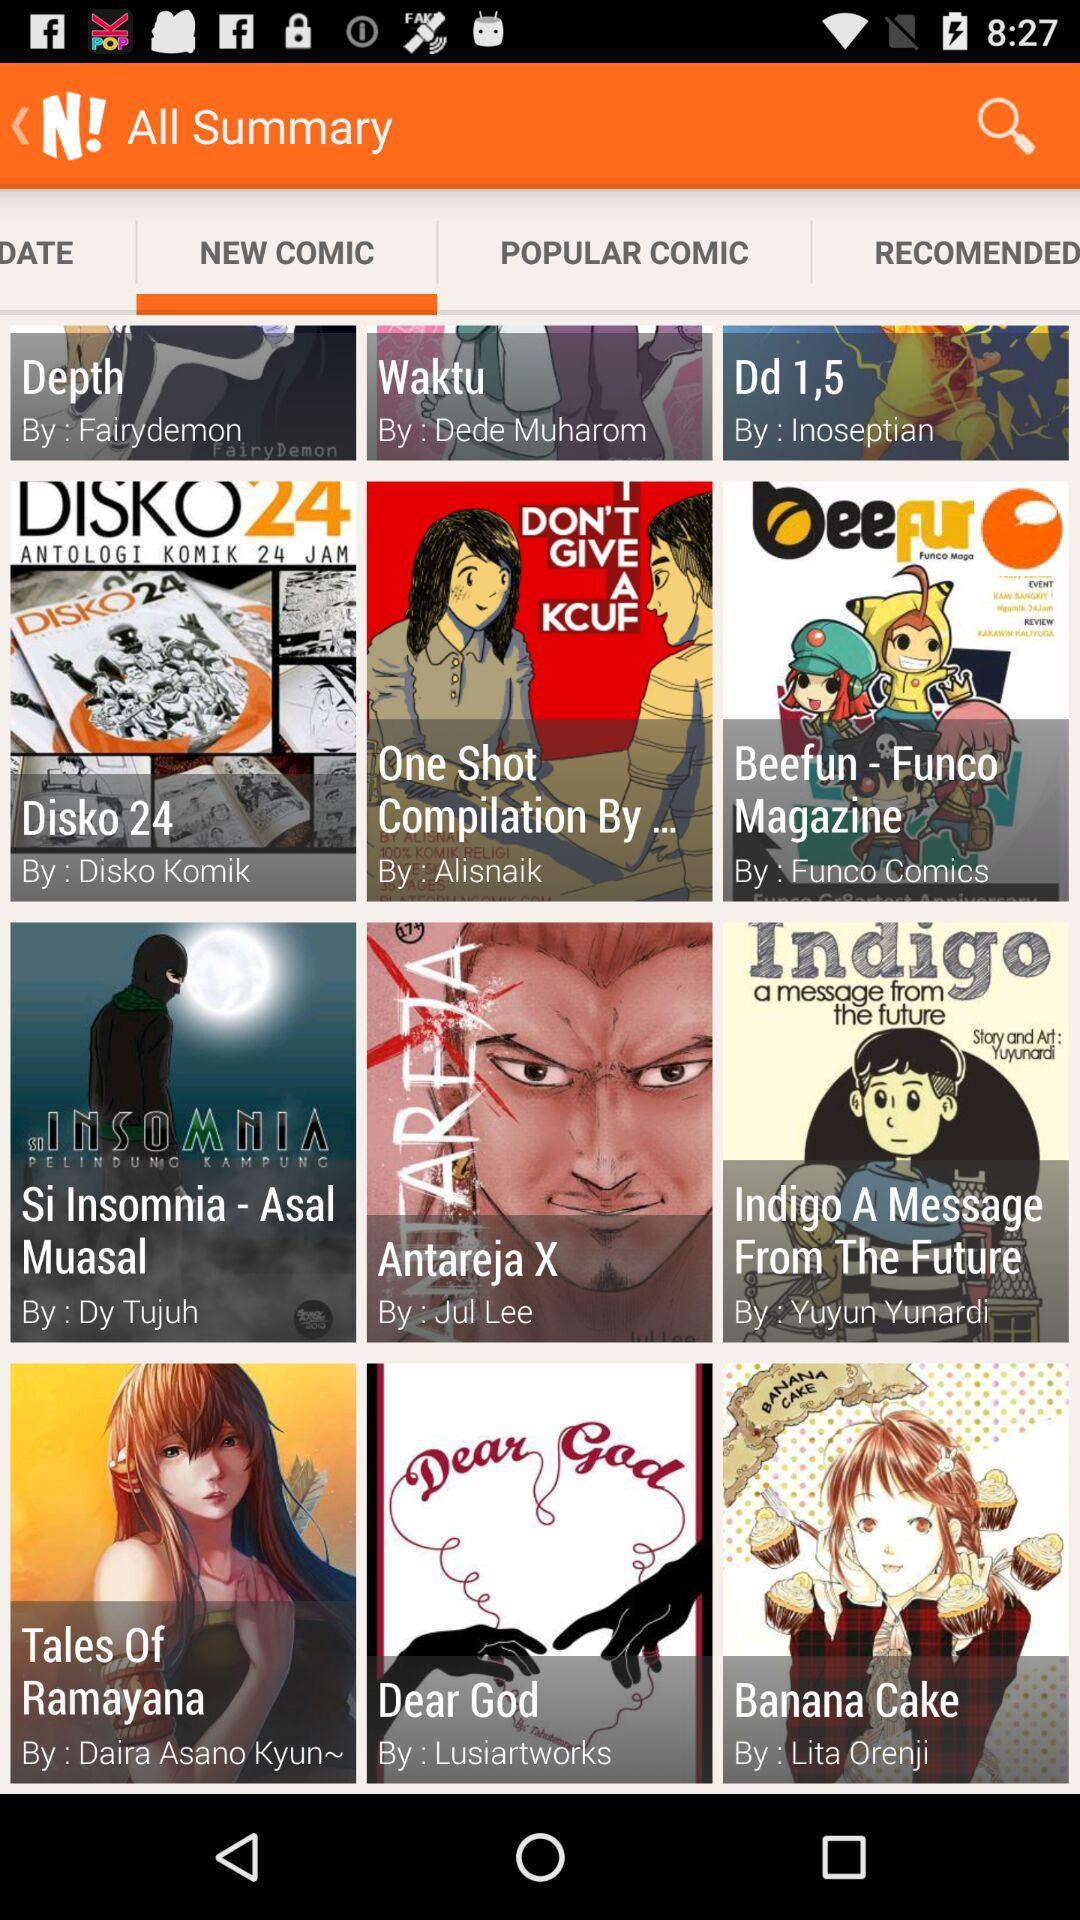Which comics are selected as popular?
When the provided information is insufficient, respond with <no answer>. <no answer> 